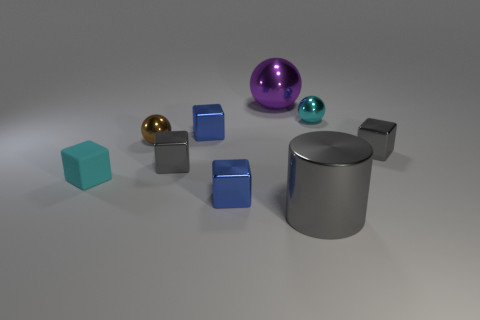Subtract all cyan cubes. How many cubes are left? 4 Add 1 small cyan balls. How many objects exist? 10 Subtract all blocks. How many objects are left? 4 Subtract 0 red cubes. How many objects are left? 9 Subtract all small cyan shiny things. Subtract all metallic spheres. How many objects are left? 5 Add 5 tiny gray metallic cubes. How many tiny gray metallic cubes are left? 7 Add 7 tiny gray shiny cubes. How many tiny gray shiny cubes exist? 9 